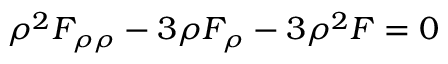Convert formula to latex. <formula><loc_0><loc_0><loc_500><loc_500>\rho ^ { 2 } F _ { \rho \rho } - 3 \rho F _ { \rho } - 3 \rho ^ { 2 } F = 0</formula> 